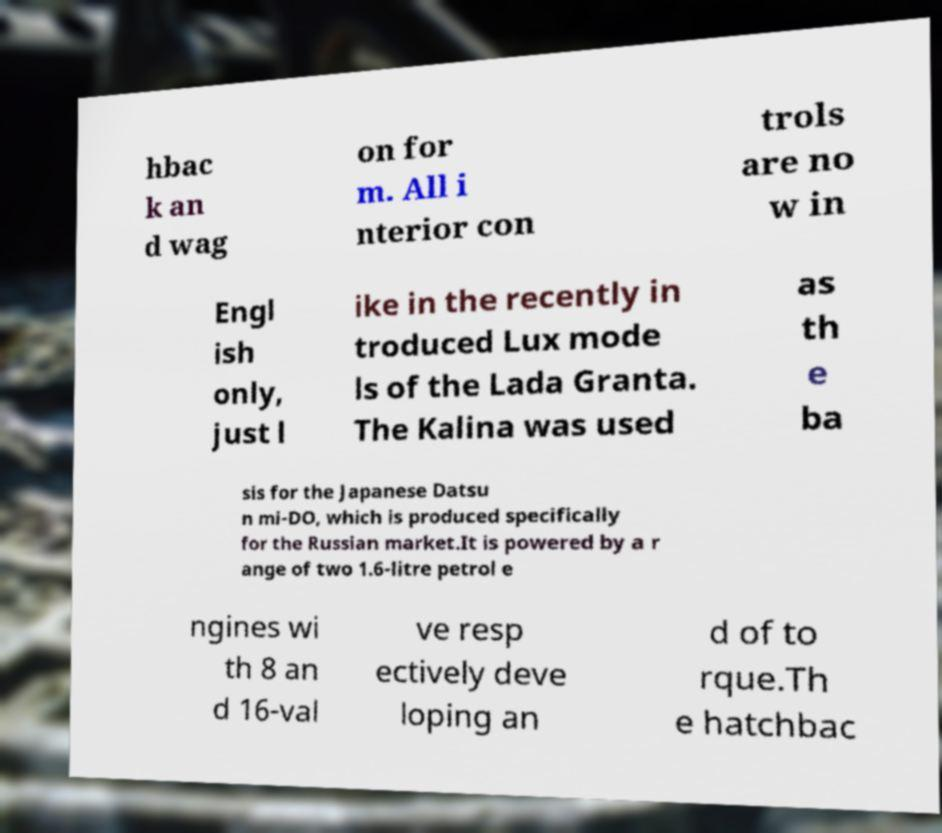I need the written content from this picture converted into text. Can you do that? hbac k an d wag on for m. All i nterior con trols are no w in Engl ish only, just l ike in the recently in troduced Lux mode ls of the Lada Granta. The Kalina was used as th e ba sis for the Japanese Datsu n mi-DO, which is produced specifically for the Russian market.It is powered by a r ange of two 1.6-litre petrol e ngines wi th 8 an d 16-val ve resp ectively deve loping an d of to rque.Th e hatchbac 